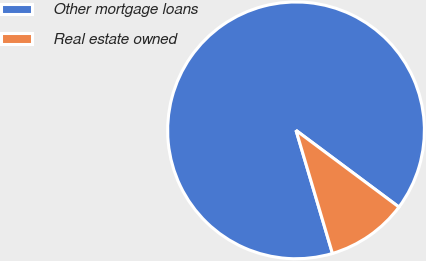Convert chart to OTSL. <chart><loc_0><loc_0><loc_500><loc_500><pie_chart><fcel>Other mortgage loans<fcel>Real estate owned<nl><fcel>89.77%<fcel>10.23%<nl></chart> 